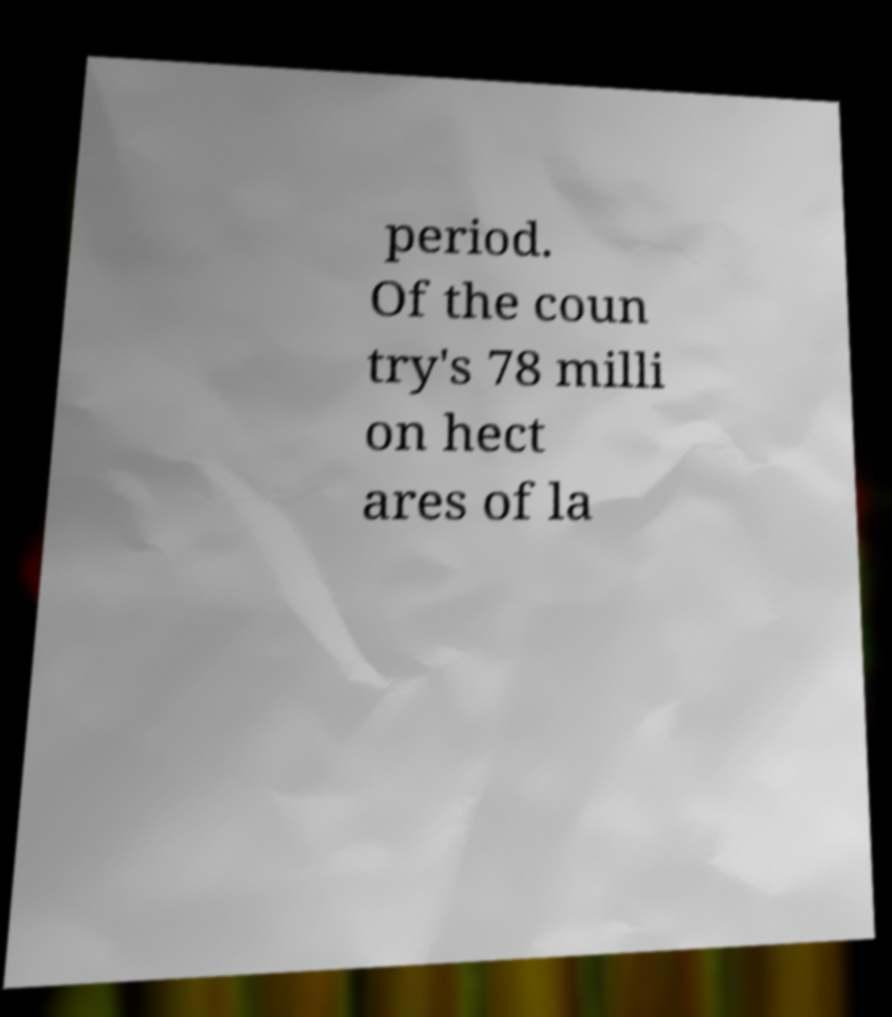I need the written content from this picture converted into text. Can you do that? period. Of the coun try's 78 milli on hect ares of la 